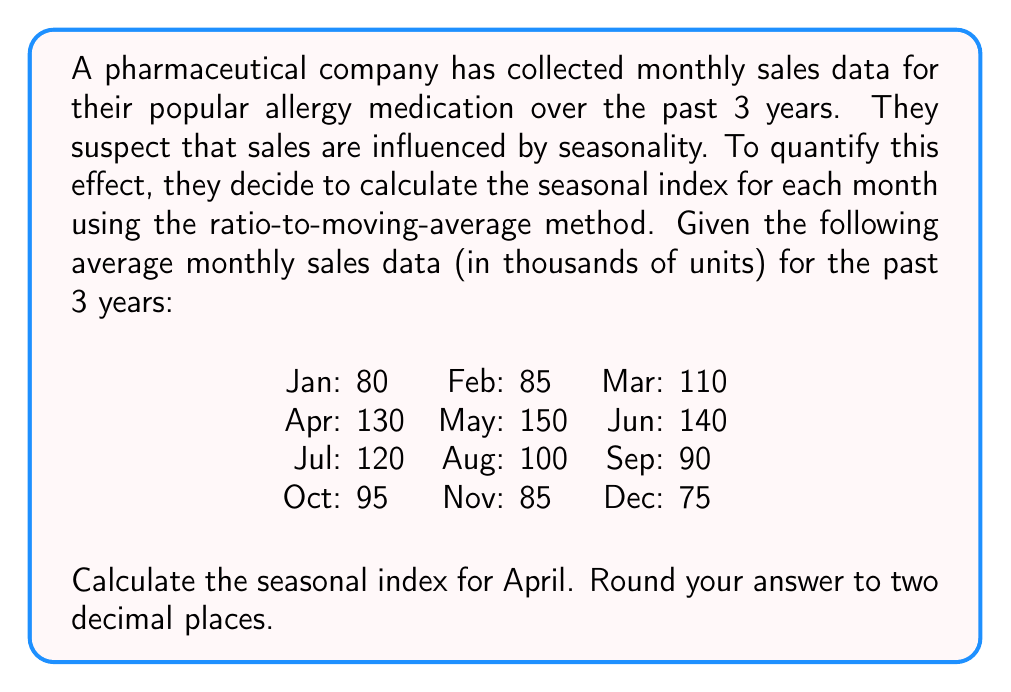Teach me how to tackle this problem. To calculate the seasonal index using the ratio-to-moving-average method, we'll follow these steps:

1. Calculate the 12-month moving average:
   First, we need to compute the centered 12-month moving average. For April, we'll use the average of March to February (next year).
   
   $MA = \frac{110 + 130 + 150 + 140 + 120 + 100 + 90 + 95 + 85 + 75 + 80 + 85}{12} = 105$

2. Calculate the ratio of the actual value to the moving average:
   April's actual value is 130, so the ratio is:
   
   $Ratio = \frac{Actual}{MA} = \frac{130}{105} = 1.2381$

3. Calculate the average ratio for April across all years:
   In this case, we're given the average data for 3 years, so this step is already done.

4. Convert the average ratio to a percentage to get the seasonal index:
   
   $Seasonal Index = Ratio \times 100\% = 1.2381 \times 100\% = 123.81\%$

5. Round to two decimal places:
   123.81%

The seasonal index of 123.81% indicates that April sales are typically 23.81% higher than the average month, likely due to increased allergy symptoms in spring.
Answer: 123.81% 